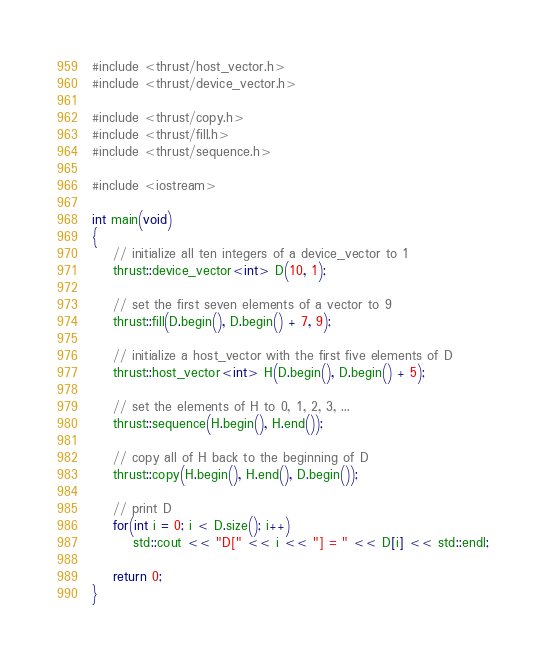Convert code to text. <code><loc_0><loc_0><loc_500><loc_500><_Cuda_>#include <thrust/host_vector.h>
#include <thrust/device_vector.h>

#include <thrust/copy.h>
#include <thrust/fill.h>
#include <thrust/sequence.h>

#include <iostream>

int main(void)
{
	// initialize all ten integers of a device_vector to 1
	thrust::device_vector<int> D(10, 1);

	// set the first seven elements of a vector to 9
	thrust::fill(D.begin(), D.begin() + 7, 9);

	// initialize a host_vector with the first five elements of D
	thrust::host_vector<int> H(D.begin(), D.begin() + 5);

	// set the elements of H to 0, 1, 2, 3, ...
	thrust::sequence(H.begin(), H.end());

	// copy all of H back to the beginning of D
	thrust::copy(H.begin(), H.end(), D.begin());

	// print D
	for(int i = 0; i < D.size(); i++)
		std::cout << "D[" << i << "] = " << D[i] << std::endl;

	return 0;
}
</code> 